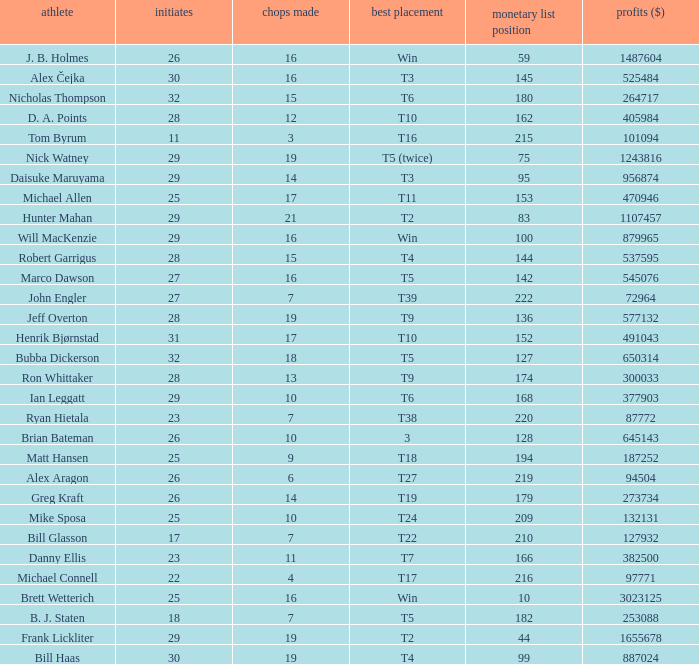What is the minimum number of starts for the players having a best finish of T18? 25.0. 